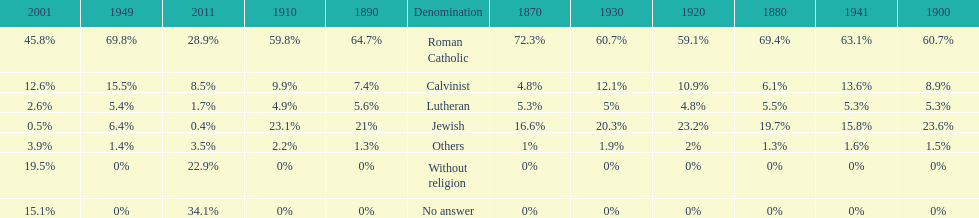In which year was the percentage of those without religion at least 20%? 2011. 